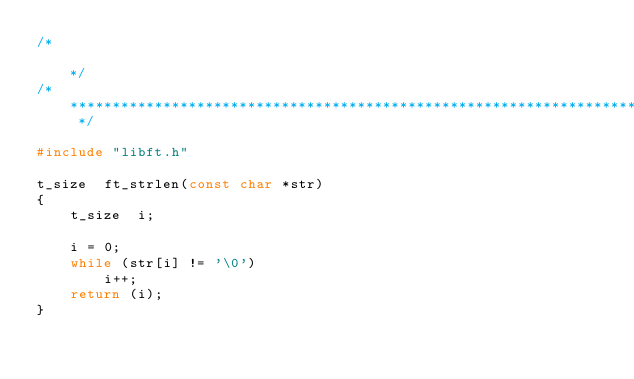<code> <loc_0><loc_0><loc_500><loc_500><_C_>/*                                                                            */
/* ************************************************************************** */

#include "libft.h"

t_size	ft_strlen(const char *str)
{
	t_size	i;

	i = 0;
	while (str[i] != '\0')
		i++;
	return (i);
}
</code> 